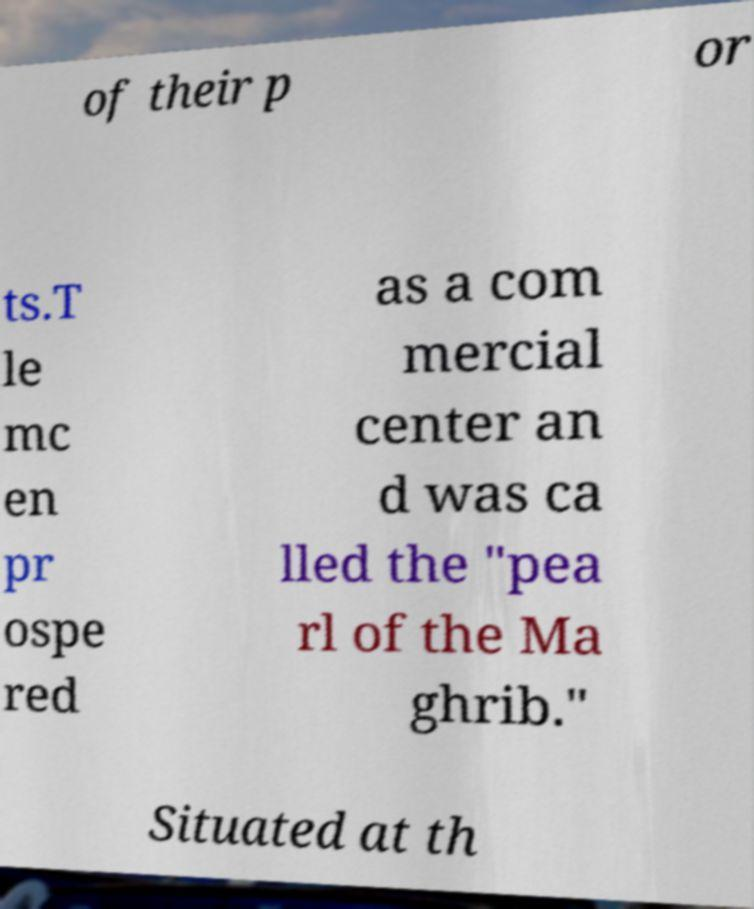Please read and relay the text visible in this image. What does it say? of their p or ts.T le mc en pr ospe red as a com mercial center an d was ca lled the "pea rl of the Ma ghrib." Situated at th 